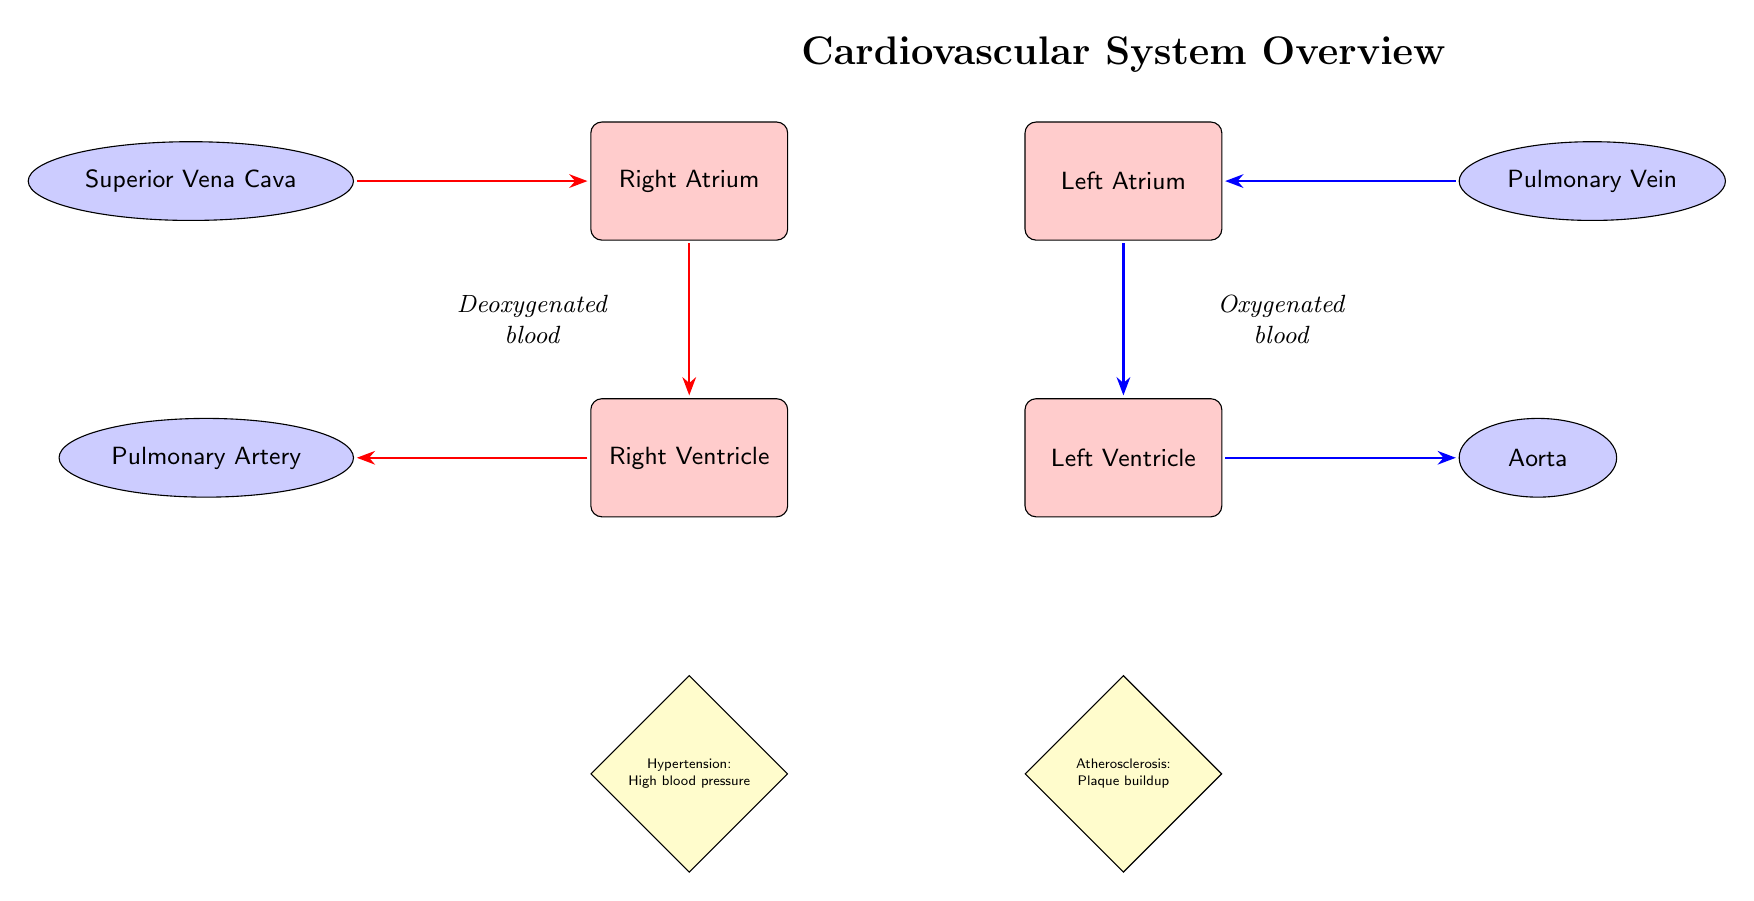What is the first chamber blood enters after the superior vena cava? The flow of blood starts from the superior vena cava, which enters the right atrium. Therefore, the first chamber blood enters is the right atrium.
Answer: Right Atrium Which artery carries deoxygenated blood from the right ventricle? The right ventricle sends deoxygenated blood to the pulmonary artery. Therefore, the artery carrying deoxygenated blood from the right ventricle is the pulmonary artery.
Answer: Pulmonary Artery How many heart conditions are noted in the diagram? There are two heart conditions listed in the diagram: hypertension and atherosclerosis. Therefore, the number of heart conditions noted is two.
Answer: 2 What type of blood flows through the pulmonary vein? The pulmonary vein carries oxygenated blood to the left atrium. Thus, the type of blood that flows through the pulmonary vein is oxygenated blood.
Answer: Oxygenated blood What follows the left ventricle in the blood flow pathway? From the left ventricle, the blood flows into the aorta. Therefore, what follows the left ventricle in the blood flow pathway is the aorta.
Answer: Aorta Which node is directly below the left atrium? The node directly below the left atrium is the left ventricle. This positional relationship identifies the left ventricle as the node directly beneath the left atrium.
Answer: Left Ventricle What condition is related to high blood pressure? The condition related to high blood pressure as shown in the diagram is hypertension. Thus, the specific condition noted is hypertension.
Answer: Hypertension Which part of the heart does the superior vena cava connect to? The superior vena cava connects to the right atrium. Therefore, the part of the heart that it connects to is the right atrium.
Answer: Right Atrium What color represents oxygenated blood in the diagram? Oxygenated blood is represented by blue in the diagram. Hence, the color that represents oxygenated blood is blue.
Answer: Blue 